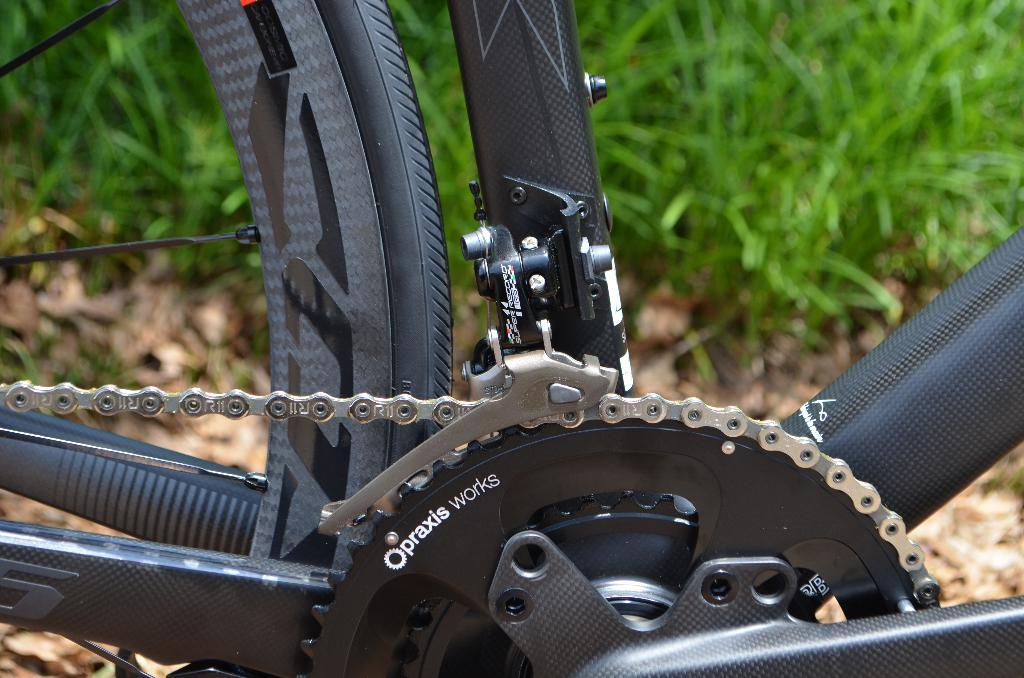What type of vegetation can be seen in the background of the image? There is green grass in the background of the image. What is partially visible in the image? A partial part of a bicycle is visible in the image. What part of the bicycle is present in the image? The bicycle's chain and tire are visible in the image. How many kittens are playing in the snow near the bicycle in the image? There are no kittens or snow present in the image; it features a bicycle with its chain and tire visible against a green grass background. 